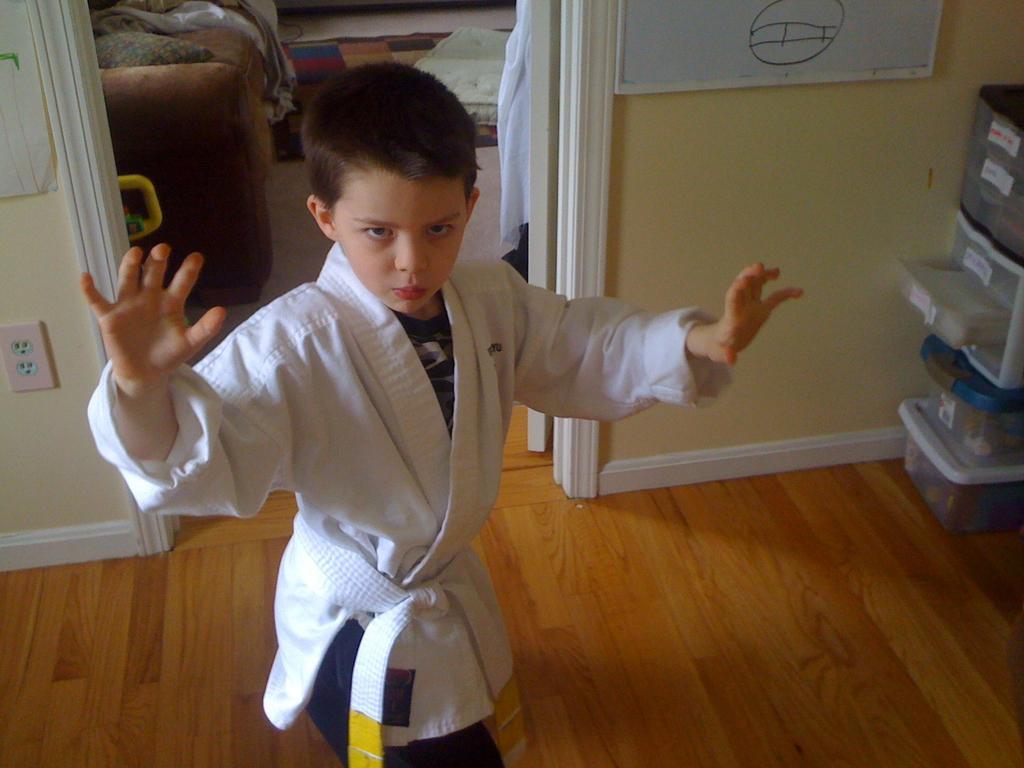Could you give a brief overview of what you see in this image? In this image we can see a person. Behind the person there is a wall, sofa, carpet and a door and on the wall we can see a white board. On the right side of the image there are some objects placed on the surface. On the left side, we can see a power socket. 